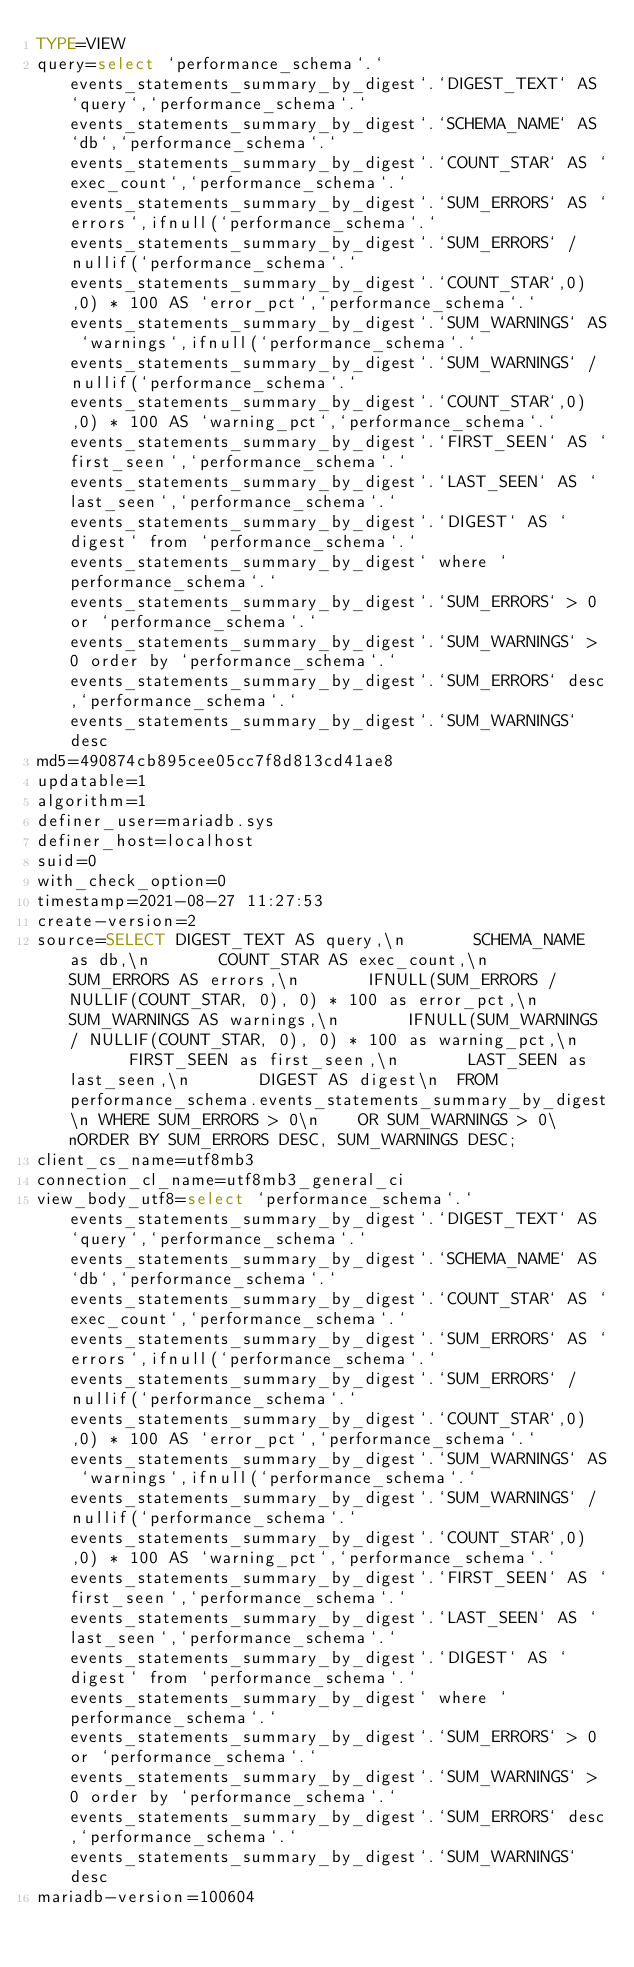<code> <loc_0><loc_0><loc_500><loc_500><_VisualBasic_>TYPE=VIEW
query=select `performance_schema`.`events_statements_summary_by_digest`.`DIGEST_TEXT` AS `query`,`performance_schema`.`events_statements_summary_by_digest`.`SCHEMA_NAME` AS `db`,`performance_schema`.`events_statements_summary_by_digest`.`COUNT_STAR` AS `exec_count`,`performance_schema`.`events_statements_summary_by_digest`.`SUM_ERRORS` AS `errors`,ifnull(`performance_schema`.`events_statements_summary_by_digest`.`SUM_ERRORS` / nullif(`performance_schema`.`events_statements_summary_by_digest`.`COUNT_STAR`,0),0) * 100 AS `error_pct`,`performance_schema`.`events_statements_summary_by_digest`.`SUM_WARNINGS` AS `warnings`,ifnull(`performance_schema`.`events_statements_summary_by_digest`.`SUM_WARNINGS` / nullif(`performance_schema`.`events_statements_summary_by_digest`.`COUNT_STAR`,0),0) * 100 AS `warning_pct`,`performance_schema`.`events_statements_summary_by_digest`.`FIRST_SEEN` AS `first_seen`,`performance_schema`.`events_statements_summary_by_digest`.`LAST_SEEN` AS `last_seen`,`performance_schema`.`events_statements_summary_by_digest`.`DIGEST` AS `digest` from `performance_schema`.`events_statements_summary_by_digest` where `performance_schema`.`events_statements_summary_by_digest`.`SUM_ERRORS` > 0 or `performance_schema`.`events_statements_summary_by_digest`.`SUM_WARNINGS` > 0 order by `performance_schema`.`events_statements_summary_by_digest`.`SUM_ERRORS` desc,`performance_schema`.`events_statements_summary_by_digest`.`SUM_WARNINGS` desc
md5=490874cb895cee05cc7f8d813cd41ae8
updatable=1
algorithm=1
definer_user=mariadb.sys
definer_host=localhost
suid=0
with_check_option=0
timestamp=2021-08-27 11:27:53
create-version=2
source=SELECT DIGEST_TEXT AS query,\n       SCHEMA_NAME as db,\n       COUNT_STAR AS exec_count,\n       SUM_ERRORS AS errors,\n       IFNULL(SUM_ERRORS / NULLIF(COUNT_STAR, 0), 0) * 100 as error_pct,\n       SUM_WARNINGS AS warnings,\n       IFNULL(SUM_WARNINGS / NULLIF(COUNT_STAR, 0), 0) * 100 as warning_pct,\n       FIRST_SEEN as first_seen,\n       LAST_SEEN as last_seen,\n       DIGEST AS digest\n  FROM performance_schema.events_statements_summary_by_digest\n WHERE SUM_ERRORS > 0\n    OR SUM_WARNINGS > 0\nORDER BY SUM_ERRORS DESC, SUM_WARNINGS DESC;
client_cs_name=utf8mb3
connection_cl_name=utf8mb3_general_ci
view_body_utf8=select `performance_schema`.`events_statements_summary_by_digest`.`DIGEST_TEXT` AS `query`,`performance_schema`.`events_statements_summary_by_digest`.`SCHEMA_NAME` AS `db`,`performance_schema`.`events_statements_summary_by_digest`.`COUNT_STAR` AS `exec_count`,`performance_schema`.`events_statements_summary_by_digest`.`SUM_ERRORS` AS `errors`,ifnull(`performance_schema`.`events_statements_summary_by_digest`.`SUM_ERRORS` / nullif(`performance_schema`.`events_statements_summary_by_digest`.`COUNT_STAR`,0),0) * 100 AS `error_pct`,`performance_schema`.`events_statements_summary_by_digest`.`SUM_WARNINGS` AS `warnings`,ifnull(`performance_schema`.`events_statements_summary_by_digest`.`SUM_WARNINGS` / nullif(`performance_schema`.`events_statements_summary_by_digest`.`COUNT_STAR`,0),0) * 100 AS `warning_pct`,`performance_schema`.`events_statements_summary_by_digest`.`FIRST_SEEN` AS `first_seen`,`performance_schema`.`events_statements_summary_by_digest`.`LAST_SEEN` AS `last_seen`,`performance_schema`.`events_statements_summary_by_digest`.`DIGEST` AS `digest` from `performance_schema`.`events_statements_summary_by_digest` where `performance_schema`.`events_statements_summary_by_digest`.`SUM_ERRORS` > 0 or `performance_schema`.`events_statements_summary_by_digest`.`SUM_WARNINGS` > 0 order by `performance_schema`.`events_statements_summary_by_digest`.`SUM_ERRORS` desc,`performance_schema`.`events_statements_summary_by_digest`.`SUM_WARNINGS` desc
mariadb-version=100604
</code> 